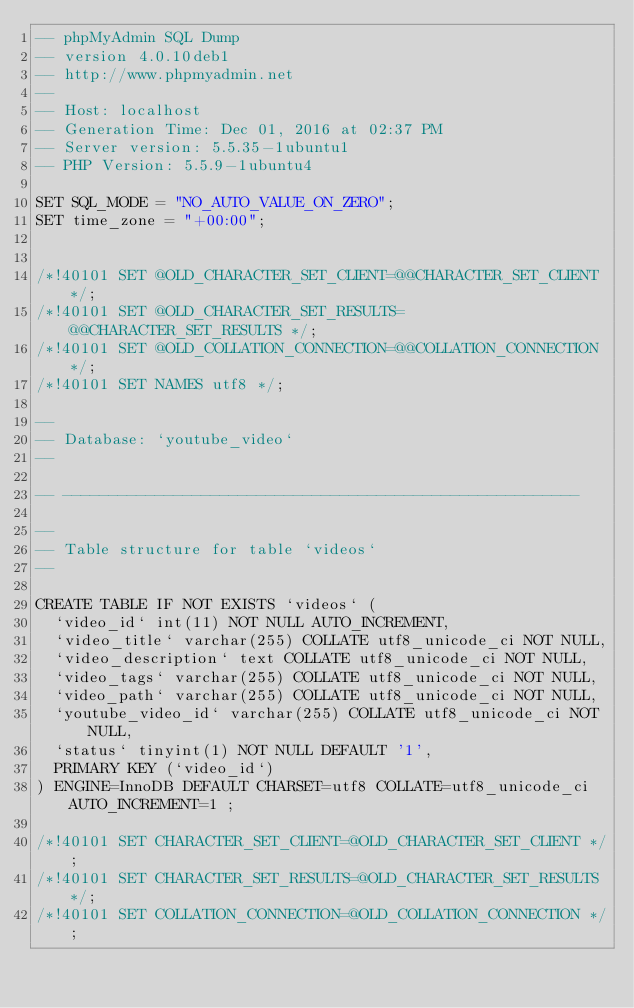<code> <loc_0><loc_0><loc_500><loc_500><_SQL_>-- phpMyAdmin SQL Dump
-- version 4.0.10deb1
-- http://www.phpmyadmin.net
--
-- Host: localhost
-- Generation Time: Dec 01, 2016 at 02:37 PM
-- Server version: 5.5.35-1ubuntu1
-- PHP Version: 5.5.9-1ubuntu4

SET SQL_MODE = "NO_AUTO_VALUE_ON_ZERO";
SET time_zone = "+00:00";


/*!40101 SET @OLD_CHARACTER_SET_CLIENT=@@CHARACTER_SET_CLIENT */;
/*!40101 SET @OLD_CHARACTER_SET_RESULTS=@@CHARACTER_SET_RESULTS */;
/*!40101 SET @OLD_COLLATION_CONNECTION=@@COLLATION_CONNECTION */;
/*!40101 SET NAMES utf8 */;

--
-- Database: `youtube_video`
--

-- --------------------------------------------------------

--
-- Table structure for table `videos`
--

CREATE TABLE IF NOT EXISTS `videos` (
  `video_id` int(11) NOT NULL AUTO_INCREMENT,
  `video_title` varchar(255) COLLATE utf8_unicode_ci NOT NULL,
  `video_description` text COLLATE utf8_unicode_ci NOT NULL,
  `video_tags` varchar(255) COLLATE utf8_unicode_ci NOT NULL,
  `video_path` varchar(255) COLLATE utf8_unicode_ci NOT NULL,
  `youtube_video_id` varchar(255) COLLATE utf8_unicode_ci NOT NULL,
  `status` tinyint(1) NOT NULL DEFAULT '1',
  PRIMARY KEY (`video_id`)
) ENGINE=InnoDB DEFAULT CHARSET=utf8 COLLATE=utf8_unicode_ci AUTO_INCREMENT=1 ;

/*!40101 SET CHARACTER_SET_CLIENT=@OLD_CHARACTER_SET_CLIENT */;
/*!40101 SET CHARACTER_SET_RESULTS=@OLD_CHARACTER_SET_RESULTS */;
/*!40101 SET COLLATION_CONNECTION=@OLD_COLLATION_CONNECTION */;
</code> 